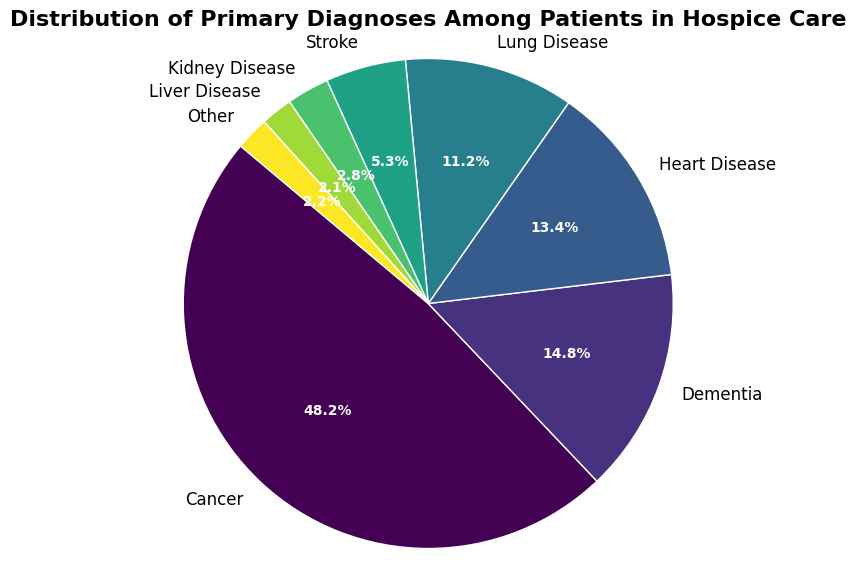What is the most common primary diagnosis among patients in hospice care? The largest segment of the pie chart represents Cancer with 48.2%. Therefore, Cancer is the most common primary diagnosis among patients in hospice care.
Answer: Cancer Which diagnosis has the smallest representation in the pie chart? By looking at the smallest segment, we find that Liver Disease represents 2.1% of the diagnoses, which is the smallest value in the pie chart.
Answer: Liver Disease How does the percentage of patients with Lung Disease compare to those with Heart Disease? Looking at the pie chart, Heart Disease has 13.4%, while Lung Disease has 11.2%. Therefore, Heart Disease has a higher percentage than Lung Disease.
Answer: Heart Disease has a higher percentage than Lung Disease What percentage of patients have either Dementia or Stroke? To find the combined percentage, add the values for Dementia (14.8%) and Stroke (5.3%): 14.8 + 5.3 = 20.1%.
Answer: 20.1% How many more percentage points does Cancer have compared to Dementia? Subtract the percentage of Dementia from Cancer: 48.2 - 14.8 = 33.4 percentage points.
Answer: 33.4 percentage points Which two diagnoses combined make up the next largest group after Cancer? By summing up the percentages, Dementia (14.8%) and Heart Disease (13.4%) add up to 28.2%, which is the next largest group after Cancer.
Answer: Dementia and Heart Disease If you were to group Dementia, Heart Disease, and Lung Disease together, what percentage of the total do they represent? Add the values for Dementia, Heart Disease, and Lung Disease: 14.8 + 13.4 + 11.2 = 39.4%.
Answer: 39.4% What is the difference in percentage between the group with the highest percentage and the group with the lowest percentage? Subtract the percentage of Liver Disease (2.1%), the smallest group, from Cancer (48.2%), the largest group: 48.2 - 2.1 = 46.1 percentage points.
Answer: 46.1 percentage points 